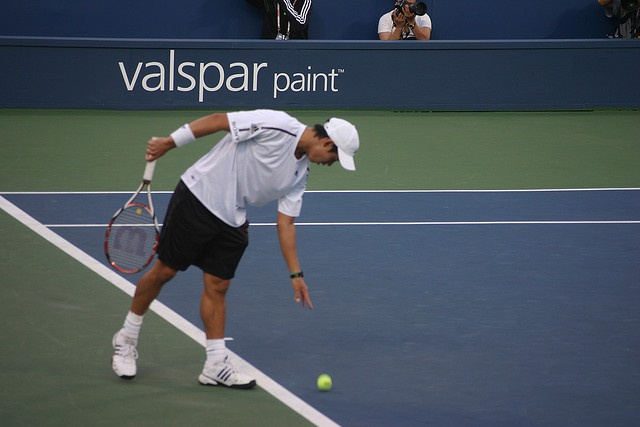Describe the objects in this image and their specific colors. I can see people in black, darkgray, lavender, and gray tones, tennis racket in black, gray, darkgray, and maroon tones, people in black, maroon, brown, and lightgray tones, people in black, white, gray, and darkgray tones, and people in black, maroon, and gray tones in this image. 